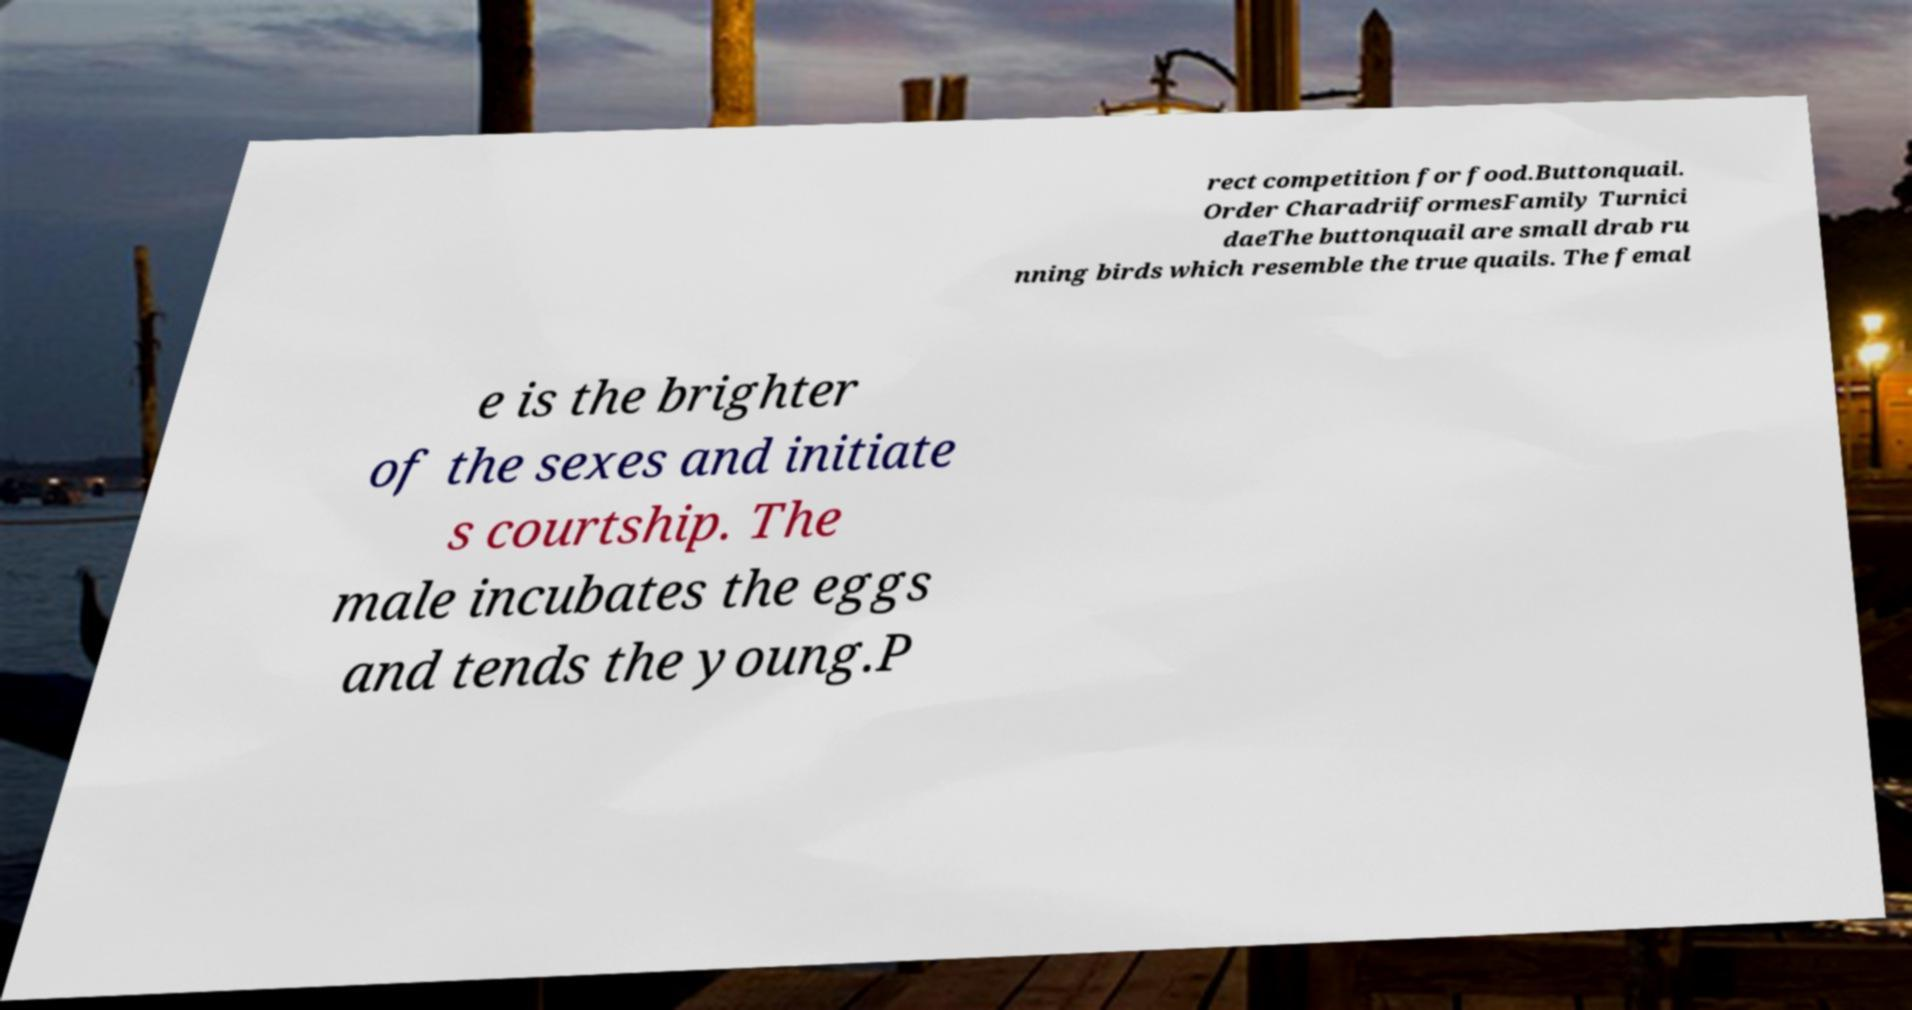I need the written content from this picture converted into text. Can you do that? rect competition for food.Buttonquail. Order CharadriiformesFamily Turnici daeThe buttonquail are small drab ru nning birds which resemble the true quails. The femal e is the brighter of the sexes and initiate s courtship. The male incubates the eggs and tends the young.P 